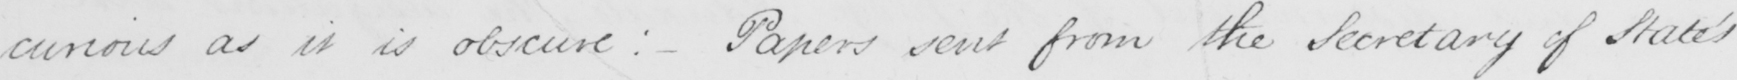Please transcribe the handwritten text in this image. curious as it is obscure :   _  Papers sent from the Secretary of State ' s 